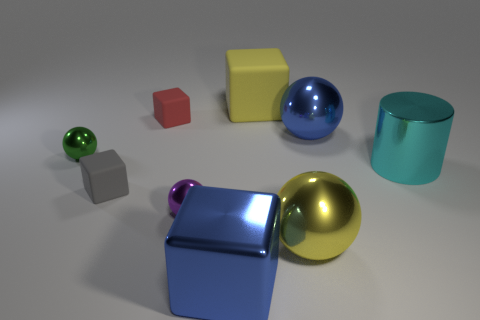Subtract all green spheres. How many spheres are left? 3 Subtract all yellow blocks. How many blocks are left? 3 Add 1 big shiny spheres. How many objects exist? 10 Subtract all brown spheres. Subtract all gray cylinders. How many spheres are left? 4 Subtract all blocks. How many objects are left? 5 Add 1 large metal cylinders. How many large metal cylinders exist? 2 Subtract 0 purple cubes. How many objects are left? 9 Subtract all large brown spheres. Subtract all big yellow blocks. How many objects are left? 8 Add 2 big blue objects. How many big blue objects are left? 4 